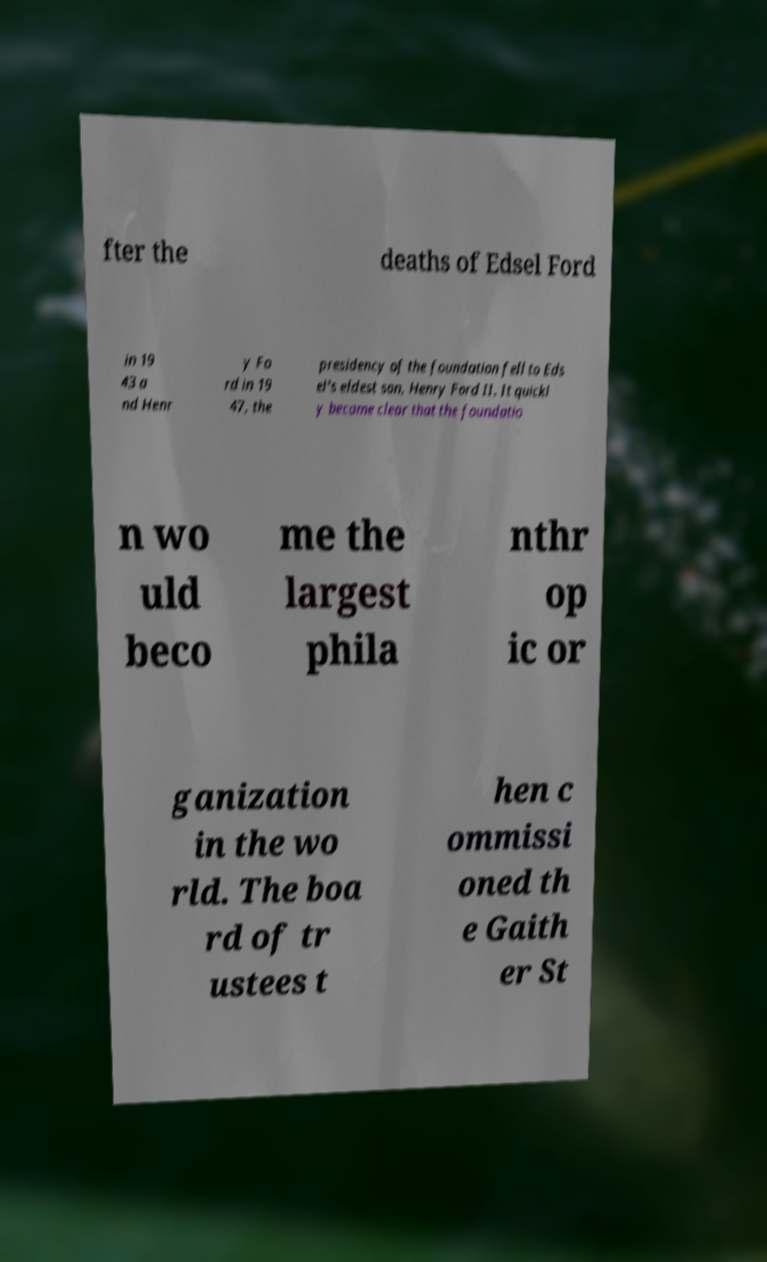I need the written content from this picture converted into text. Can you do that? fter the deaths of Edsel Ford in 19 43 a nd Henr y Fo rd in 19 47, the presidency of the foundation fell to Eds el's eldest son, Henry Ford II. It quickl y became clear that the foundatio n wo uld beco me the largest phila nthr op ic or ganization in the wo rld. The boa rd of tr ustees t hen c ommissi oned th e Gaith er St 